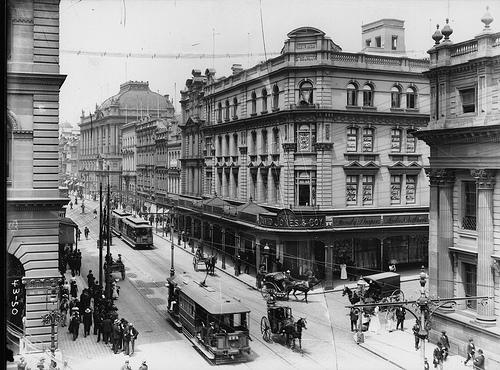Was this picture taken recently?
Keep it brief. No. Is the picture real?
Write a very short answer. Yes. Is this transportation used today?
Be succinct. No. 